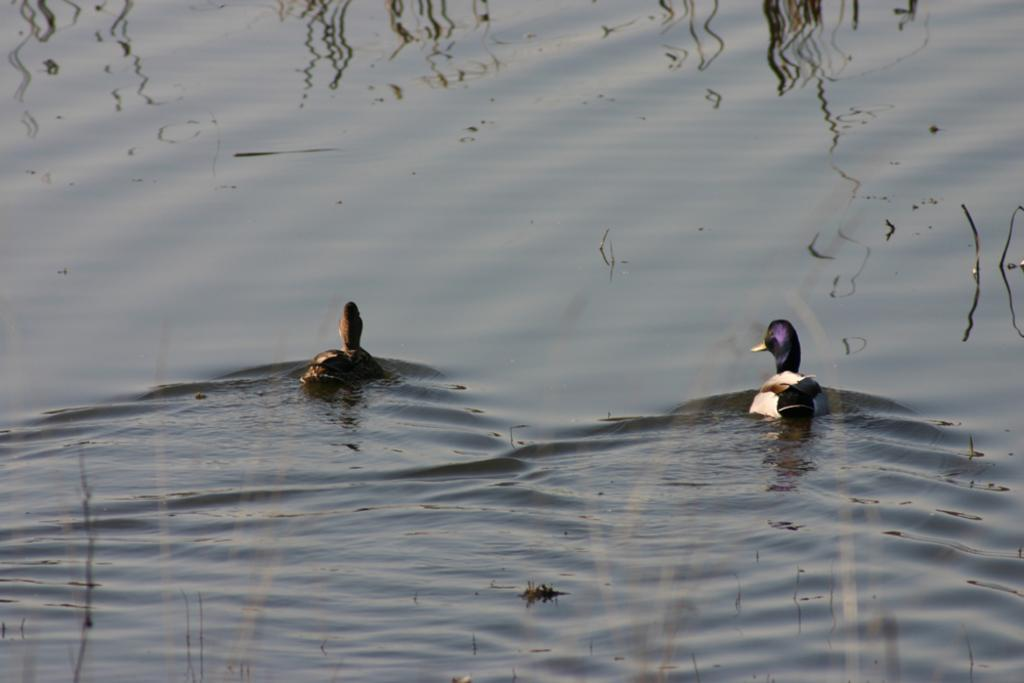What type of animals are in the water in the image? There are ducks in the water in the image. What can be seen in the background of the image? The background of the image includes the shadow of trees. What type of agreement is being discussed in the book that is visible in the image? There is no book present in the image, so no agreement can be discussed. What note is the duck holding in its beak in the image? There is no note visible in the image; the ducks are in the water without any objects in their beaks. 